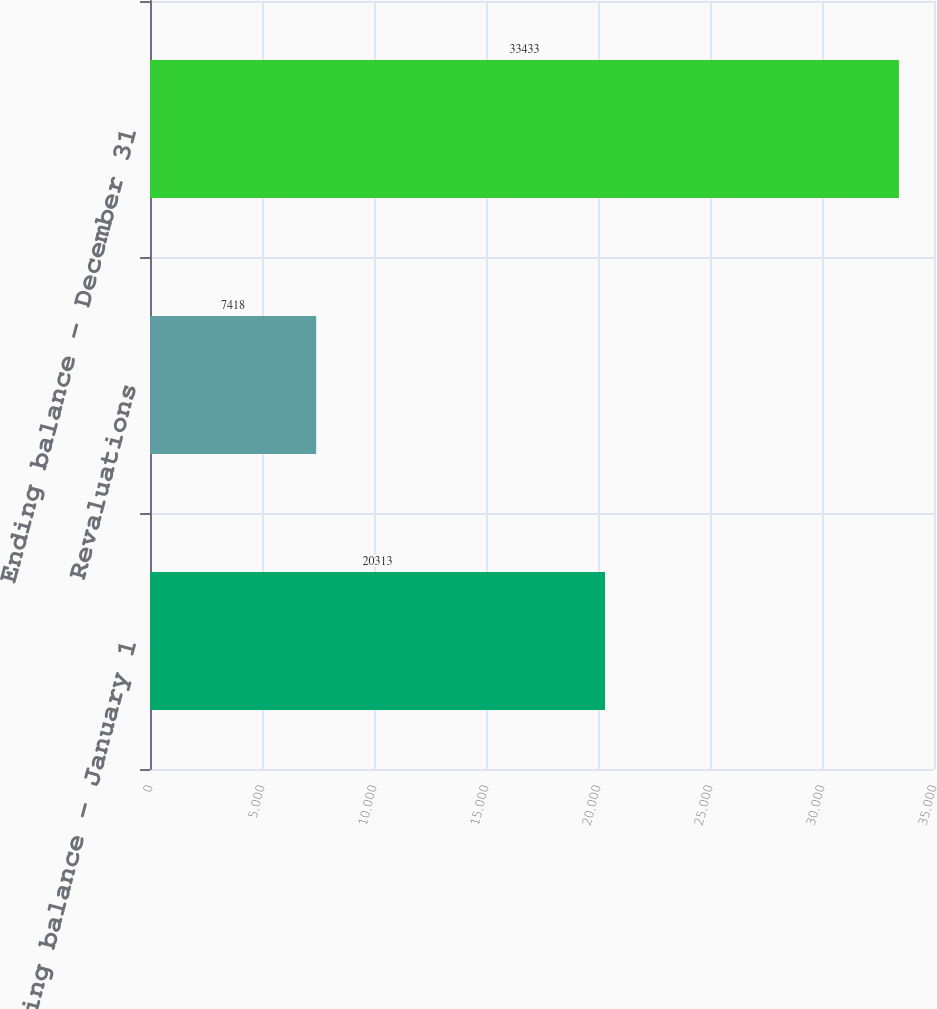Convert chart. <chart><loc_0><loc_0><loc_500><loc_500><bar_chart><fcel>Beginning balance - January 1<fcel>Revaluations<fcel>Ending balance - December 31<nl><fcel>20313<fcel>7418<fcel>33433<nl></chart> 